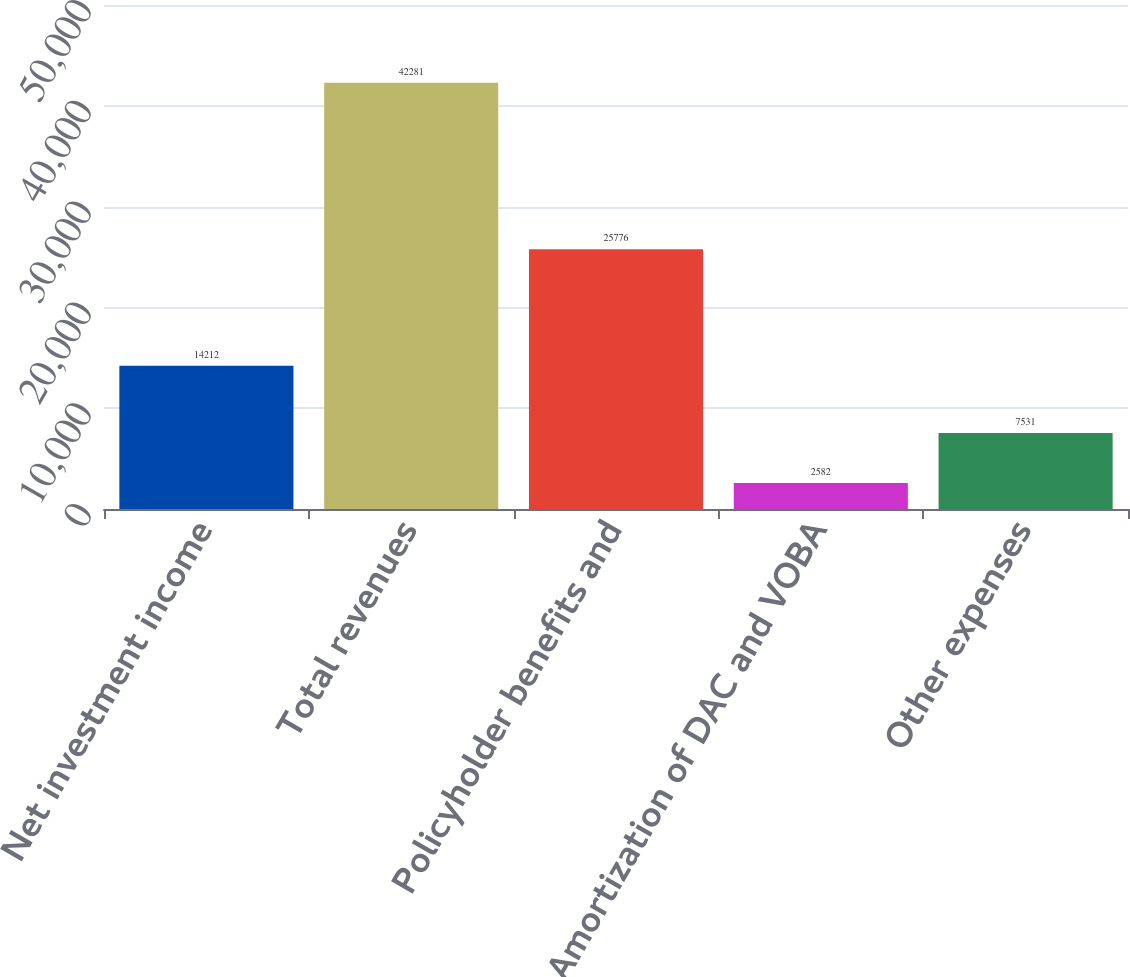<chart> <loc_0><loc_0><loc_500><loc_500><bar_chart><fcel>Net investment income<fcel>Total revenues<fcel>Policyholder benefits and<fcel>Amortization of DAC and VOBA<fcel>Other expenses<nl><fcel>14212<fcel>42281<fcel>25776<fcel>2582<fcel>7531<nl></chart> 